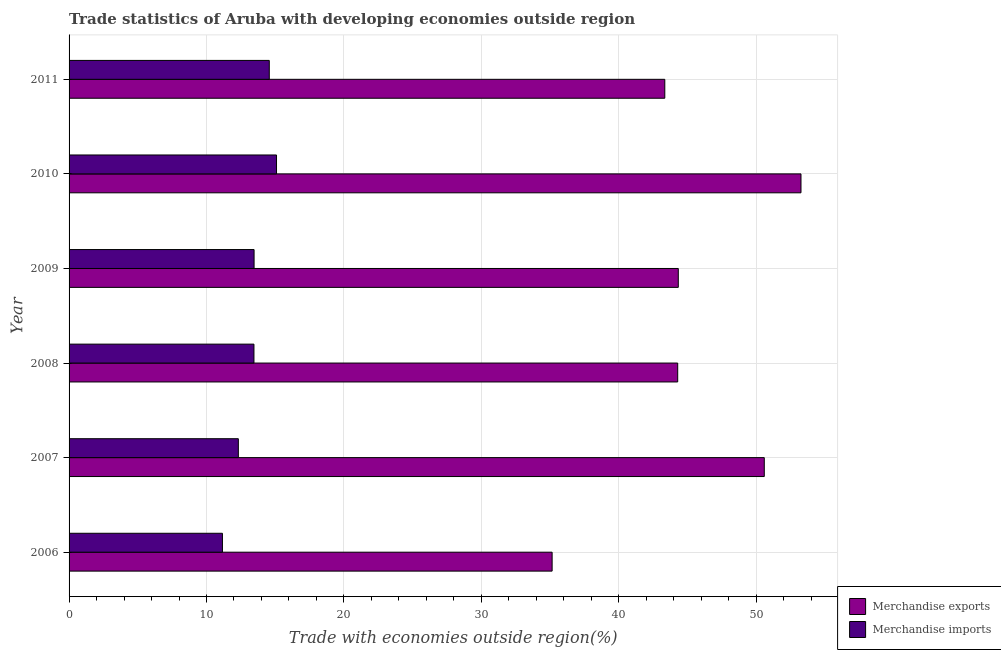How many different coloured bars are there?
Make the answer very short. 2. Are the number of bars per tick equal to the number of legend labels?
Ensure brevity in your answer.  Yes. Are the number of bars on each tick of the Y-axis equal?
Keep it short and to the point. Yes. How many bars are there on the 4th tick from the top?
Your response must be concise. 2. How many bars are there on the 6th tick from the bottom?
Give a very brief answer. 2. What is the label of the 4th group of bars from the top?
Your answer should be very brief. 2008. In how many cases, is the number of bars for a given year not equal to the number of legend labels?
Provide a short and direct response. 0. What is the merchandise imports in 2011?
Your answer should be very brief. 14.57. Across all years, what is the maximum merchandise exports?
Keep it short and to the point. 53.26. Across all years, what is the minimum merchandise exports?
Your response must be concise. 35.15. In which year was the merchandise imports maximum?
Offer a terse response. 2010. What is the total merchandise exports in the graph?
Give a very brief answer. 270.96. What is the difference between the merchandise imports in 2006 and that in 2010?
Provide a short and direct response. -3.94. What is the difference between the merchandise exports in 2009 and the merchandise imports in 2006?
Keep it short and to the point. 33.17. What is the average merchandise imports per year?
Provide a succinct answer. 13.34. In the year 2008, what is the difference between the merchandise exports and merchandise imports?
Your answer should be compact. 30.83. Is the merchandise exports in 2010 less than that in 2011?
Your answer should be compact. No. Is the difference between the merchandise imports in 2007 and 2010 greater than the difference between the merchandise exports in 2007 and 2010?
Offer a very short reply. No. What is the difference between the highest and the second highest merchandise imports?
Your answer should be compact. 0.53. What is the difference between the highest and the lowest merchandise exports?
Ensure brevity in your answer.  18.11. In how many years, is the merchandise imports greater than the average merchandise imports taken over all years?
Your response must be concise. 4. Is the sum of the merchandise exports in 2006 and 2007 greater than the maximum merchandise imports across all years?
Ensure brevity in your answer.  Yes. What does the 2nd bar from the top in 2011 represents?
Ensure brevity in your answer.  Merchandise exports. What does the 2nd bar from the bottom in 2010 represents?
Give a very brief answer. Merchandise imports. How many bars are there?
Make the answer very short. 12. Are all the bars in the graph horizontal?
Provide a succinct answer. Yes. How many years are there in the graph?
Give a very brief answer. 6. Are the values on the major ticks of X-axis written in scientific E-notation?
Keep it short and to the point. No. Does the graph contain grids?
Keep it short and to the point. Yes. What is the title of the graph?
Give a very brief answer. Trade statistics of Aruba with developing economies outside region. Does "Fixed telephone" appear as one of the legend labels in the graph?
Offer a terse response. No. What is the label or title of the X-axis?
Your answer should be compact. Trade with economies outside region(%). What is the label or title of the Y-axis?
Your answer should be compact. Year. What is the Trade with economies outside region(%) of Merchandise exports in 2006?
Offer a terse response. 35.15. What is the Trade with economies outside region(%) in Merchandise imports in 2006?
Your answer should be compact. 11.16. What is the Trade with economies outside region(%) in Merchandise exports in 2007?
Provide a short and direct response. 50.59. What is the Trade with economies outside region(%) in Merchandise imports in 2007?
Offer a very short reply. 12.32. What is the Trade with economies outside region(%) of Merchandise exports in 2008?
Ensure brevity in your answer.  44.29. What is the Trade with economies outside region(%) of Merchandise imports in 2008?
Your answer should be very brief. 13.45. What is the Trade with economies outside region(%) in Merchandise exports in 2009?
Offer a very short reply. 44.33. What is the Trade with economies outside region(%) in Merchandise imports in 2009?
Keep it short and to the point. 13.46. What is the Trade with economies outside region(%) in Merchandise exports in 2010?
Provide a succinct answer. 53.26. What is the Trade with economies outside region(%) in Merchandise imports in 2010?
Provide a short and direct response. 15.1. What is the Trade with economies outside region(%) in Merchandise exports in 2011?
Offer a very short reply. 43.35. What is the Trade with economies outside region(%) of Merchandise imports in 2011?
Your answer should be very brief. 14.57. Across all years, what is the maximum Trade with economies outside region(%) of Merchandise exports?
Provide a short and direct response. 53.26. Across all years, what is the maximum Trade with economies outside region(%) of Merchandise imports?
Provide a succinct answer. 15.1. Across all years, what is the minimum Trade with economies outside region(%) of Merchandise exports?
Give a very brief answer. 35.15. Across all years, what is the minimum Trade with economies outside region(%) of Merchandise imports?
Offer a terse response. 11.16. What is the total Trade with economies outside region(%) in Merchandise exports in the graph?
Provide a succinct answer. 270.96. What is the total Trade with economies outside region(%) of Merchandise imports in the graph?
Your answer should be very brief. 80.06. What is the difference between the Trade with economies outside region(%) of Merchandise exports in 2006 and that in 2007?
Provide a succinct answer. -15.44. What is the difference between the Trade with economies outside region(%) of Merchandise imports in 2006 and that in 2007?
Keep it short and to the point. -1.16. What is the difference between the Trade with economies outside region(%) in Merchandise exports in 2006 and that in 2008?
Ensure brevity in your answer.  -9.14. What is the difference between the Trade with economies outside region(%) of Merchandise imports in 2006 and that in 2008?
Ensure brevity in your answer.  -2.29. What is the difference between the Trade with economies outside region(%) of Merchandise exports in 2006 and that in 2009?
Provide a succinct answer. -9.18. What is the difference between the Trade with economies outside region(%) in Merchandise imports in 2006 and that in 2009?
Your answer should be very brief. -2.3. What is the difference between the Trade with economies outside region(%) in Merchandise exports in 2006 and that in 2010?
Your response must be concise. -18.11. What is the difference between the Trade with economies outside region(%) in Merchandise imports in 2006 and that in 2010?
Your answer should be very brief. -3.94. What is the difference between the Trade with economies outside region(%) of Merchandise exports in 2006 and that in 2011?
Give a very brief answer. -8.2. What is the difference between the Trade with economies outside region(%) of Merchandise imports in 2006 and that in 2011?
Your response must be concise. -3.41. What is the difference between the Trade with economies outside region(%) in Merchandise exports in 2007 and that in 2008?
Your response must be concise. 6.3. What is the difference between the Trade with economies outside region(%) of Merchandise imports in 2007 and that in 2008?
Make the answer very short. -1.14. What is the difference between the Trade with economies outside region(%) of Merchandise exports in 2007 and that in 2009?
Offer a very short reply. 6.26. What is the difference between the Trade with economies outside region(%) in Merchandise imports in 2007 and that in 2009?
Your answer should be compact. -1.14. What is the difference between the Trade with economies outside region(%) of Merchandise exports in 2007 and that in 2010?
Make the answer very short. -2.67. What is the difference between the Trade with economies outside region(%) in Merchandise imports in 2007 and that in 2010?
Your answer should be very brief. -2.78. What is the difference between the Trade with economies outside region(%) of Merchandise exports in 2007 and that in 2011?
Offer a terse response. 7.24. What is the difference between the Trade with economies outside region(%) in Merchandise imports in 2007 and that in 2011?
Make the answer very short. -2.25. What is the difference between the Trade with economies outside region(%) in Merchandise exports in 2008 and that in 2009?
Provide a succinct answer. -0.04. What is the difference between the Trade with economies outside region(%) of Merchandise imports in 2008 and that in 2009?
Your answer should be very brief. -0.01. What is the difference between the Trade with economies outside region(%) of Merchandise exports in 2008 and that in 2010?
Make the answer very short. -8.97. What is the difference between the Trade with economies outside region(%) of Merchandise imports in 2008 and that in 2010?
Ensure brevity in your answer.  -1.64. What is the difference between the Trade with economies outside region(%) of Merchandise exports in 2008 and that in 2011?
Provide a short and direct response. 0.94. What is the difference between the Trade with economies outside region(%) in Merchandise imports in 2008 and that in 2011?
Offer a very short reply. -1.11. What is the difference between the Trade with economies outside region(%) in Merchandise exports in 2009 and that in 2010?
Your answer should be compact. -8.93. What is the difference between the Trade with economies outside region(%) in Merchandise imports in 2009 and that in 2010?
Your answer should be compact. -1.63. What is the difference between the Trade with economies outside region(%) of Merchandise exports in 2009 and that in 2011?
Give a very brief answer. 0.98. What is the difference between the Trade with economies outside region(%) in Merchandise imports in 2009 and that in 2011?
Make the answer very short. -1.11. What is the difference between the Trade with economies outside region(%) of Merchandise exports in 2010 and that in 2011?
Offer a very short reply. 9.91. What is the difference between the Trade with economies outside region(%) of Merchandise imports in 2010 and that in 2011?
Provide a succinct answer. 0.53. What is the difference between the Trade with economies outside region(%) of Merchandise exports in 2006 and the Trade with economies outside region(%) of Merchandise imports in 2007?
Provide a succinct answer. 22.83. What is the difference between the Trade with economies outside region(%) in Merchandise exports in 2006 and the Trade with economies outside region(%) in Merchandise imports in 2008?
Your answer should be compact. 21.7. What is the difference between the Trade with economies outside region(%) in Merchandise exports in 2006 and the Trade with economies outside region(%) in Merchandise imports in 2009?
Your response must be concise. 21.69. What is the difference between the Trade with economies outside region(%) in Merchandise exports in 2006 and the Trade with economies outside region(%) in Merchandise imports in 2010?
Offer a very short reply. 20.05. What is the difference between the Trade with economies outside region(%) in Merchandise exports in 2006 and the Trade with economies outside region(%) in Merchandise imports in 2011?
Give a very brief answer. 20.58. What is the difference between the Trade with economies outside region(%) of Merchandise exports in 2007 and the Trade with economies outside region(%) of Merchandise imports in 2008?
Offer a very short reply. 37.13. What is the difference between the Trade with economies outside region(%) in Merchandise exports in 2007 and the Trade with economies outside region(%) in Merchandise imports in 2009?
Offer a very short reply. 37.13. What is the difference between the Trade with economies outside region(%) in Merchandise exports in 2007 and the Trade with economies outside region(%) in Merchandise imports in 2010?
Keep it short and to the point. 35.49. What is the difference between the Trade with economies outside region(%) of Merchandise exports in 2007 and the Trade with economies outside region(%) of Merchandise imports in 2011?
Offer a terse response. 36.02. What is the difference between the Trade with economies outside region(%) of Merchandise exports in 2008 and the Trade with economies outside region(%) of Merchandise imports in 2009?
Your response must be concise. 30.83. What is the difference between the Trade with economies outside region(%) of Merchandise exports in 2008 and the Trade with economies outside region(%) of Merchandise imports in 2010?
Provide a succinct answer. 29.19. What is the difference between the Trade with economies outside region(%) of Merchandise exports in 2008 and the Trade with economies outside region(%) of Merchandise imports in 2011?
Make the answer very short. 29.72. What is the difference between the Trade with economies outside region(%) of Merchandise exports in 2009 and the Trade with economies outside region(%) of Merchandise imports in 2010?
Offer a very short reply. 29.24. What is the difference between the Trade with economies outside region(%) of Merchandise exports in 2009 and the Trade with economies outside region(%) of Merchandise imports in 2011?
Provide a short and direct response. 29.76. What is the difference between the Trade with economies outside region(%) of Merchandise exports in 2010 and the Trade with economies outside region(%) of Merchandise imports in 2011?
Offer a very short reply. 38.69. What is the average Trade with economies outside region(%) of Merchandise exports per year?
Provide a succinct answer. 45.16. What is the average Trade with economies outside region(%) of Merchandise imports per year?
Keep it short and to the point. 13.34. In the year 2006, what is the difference between the Trade with economies outside region(%) of Merchandise exports and Trade with economies outside region(%) of Merchandise imports?
Ensure brevity in your answer.  23.99. In the year 2007, what is the difference between the Trade with economies outside region(%) of Merchandise exports and Trade with economies outside region(%) of Merchandise imports?
Offer a terse response. 38.27. In the year 2008, what is the difference between the Trade with economies outside region(%) of Merchandise exports and Trade with economies outside region(%) of Merchandise imports?
Provide a succinct answer. 30.83. In the year 2009, what is the difference between the Trade with economies outside region(%) of Merchandise exports and Trade with economies outside region(%) of Merchandise imports?
Give a very brief answer. 30.87. In the year 2010, what is the difference between the Trade with economies outside region(%) of Merchandise exports and Trade with economies outside region(%) of Merchandise imports?
Offer a terse response. 38.16. In the year 2011, what is the difference between the Trade with economies outside region(%) of Merchandise exports and Trade with economies outside region(%) of Merchandise imports?
Your response must be concise. 28.78. What is the ratio of the Trade with economies outside region(%) in Merchandise exports in 2006 to that in 2007?
Make the answer very short. 0.69. What is the ratio of the Trade with economies outside region(%) of Merchandise imports in 2006 to that in 2007?
Provide a short and direct response. 0.91. What is the ratio of the Trade with economies outside region(%) in Merchandise exports in 2006 to that in 2008?
Your answer should be compact. 0.79. What is the ratio of the Trade with economies outside region(%) of Merchandise imports in 2006 to that in 2008?
Your answer should be very brief. 0.83. What is the ratio of the Trade with economies outside region(%) of Merchandise exports in 2006 to that in 2009?
Your response must be concise. 0.79. What is the ratio of the Trade with economies outside region(%) in Merchandise imports in 2006 to that in 2009?
Give a very brief answer. 0.83. What is the ratio of the Trade with economies outside region(%) in Merchandise exports in 2006 to that in 2010?
Provide a short and direct response. 0.66. What is the ratio of the Trade with economies outside region(%) in Merchandise imports in 2006 to that in 2010?
Make the answer very short. 0.74. What is the ratio of the Trade with economies outside region(%) of Merchandise exports in 2006 to that in 2011?
Provide a short and direct response. 0.81. What is the ratio of the Trade with economies outside region(%) of Merchandise imports in 2006 to that in 2011?
Ensure brevity in your answer.  0.77. What is the ratio of the Trade with economies outside region(%) in Merchandise exports in 2007 to that in 2008?
Offer a terse response. 1.14. What is the ratio of the Trade with economies outside region(%) in Merchandise imports in 2007 to that in 2008?
Provide a short and direct response. 0.92. What is the ratio of the Trade with economies outside region(%) in Merchandise exports in 2007 to that in 2009?
Ensure brevity in your answer.  1.14. What is the ratio of the Trade with economies outside region(%) of Merchandise imports in 2007 to that in 2009?
Give a very brief answer. 0.92. What is the ratio of the Trade with economies outside region(%) of Merchandise exports in 2007 to that in 2010?
Your answer should be very brief. 0.95. What is the ratio of the Trade with economies outside region(%) of Merchandise imports in 2007 to that in 2010?
Your answer should be compact. 0.82. What is the ratio of the Trade with economies outside region(%) of Merchandise exports in 2007 to that in 2011?
Provide a short and direct response. 1.17. What is the ratio of the Trade with economies outside region(%) in Merchandise imports in 2007 to that in 2011?
Your response must be concise. 0.85. What is the ratio of the Trade with economies outside region(%) of Merchandise exports in 2008 to that in 2009?
Offer a very short reply. 1. What is the ratio of the Trade with economies outside region(%) of Merchandise imports in 2008 to that in 2009?
Give a very brief answer. 1. What is the ratio of the Trade with economies outside region(%) in Merchandise exports in 2008 to that in 2010?
Keep it short and to the point. 0.83. What is the ratio of the Trade with economies outside region(%) in Merchandise imports in 2008 to that in 2010?
Give a very brief answer. 0.89. What is the ratio of the Trade with economies outside region(%) in Merchandise exports in 2008 to that in 2011?
Make the answer very short. 1.02. What is the ratio of the Trade with economies outside region(%) of Merchandise imports in 2008 to that in 2011?
Your response must be concise. 0.92. What is the ratio of the Trade with economies outside region(%) in Merchandise exports in 2009 to that in 2010?
Your answer should be very brief. 0.83. What is the ratio of the Trade with economies outside region(%) of Merchandise imports in 2009 to that in 2010?
Offer a terse response. 0.89. What is the ratio of the Trade with economies outside region(%) in Merchandise exports in 2009 to that in 2011?
Your response must be concise. 1.02. What is the ratio of the Trade with economies outside region(%) in Merchandise imports in 2009 to that in 2011?
Make the answer very short. 0.92. What is the ratio of the Trade with economies outside region(%) in Merchandise exports in 2010 to that in 2011?
Your answer should be compact. 1.23. What is the ratio of the Trade with economies outside region(%) of Merchandise imports in 2010 to that in 2011?
Ensure brevity in your answer.  1.04. What is the difference between the highest and the second highest Trade with economies outside region(%) in Merchandise exports?
Provide a short and direct response. 2.67. What is the difference between the highest and the second highest Trade with economies outside region(%) in Merchandise imports?
Ensure brevity in your answer.  0.53. What is the difference between the highest and the lowest Trade with economies outside region(%) in Merchandise exports?
Keep it short and to the point. 18.11. What is the difference between the highest and the lowest Trade with economies outside region(%) of Merchandise imports?
Offer a terse response. 3.94. 